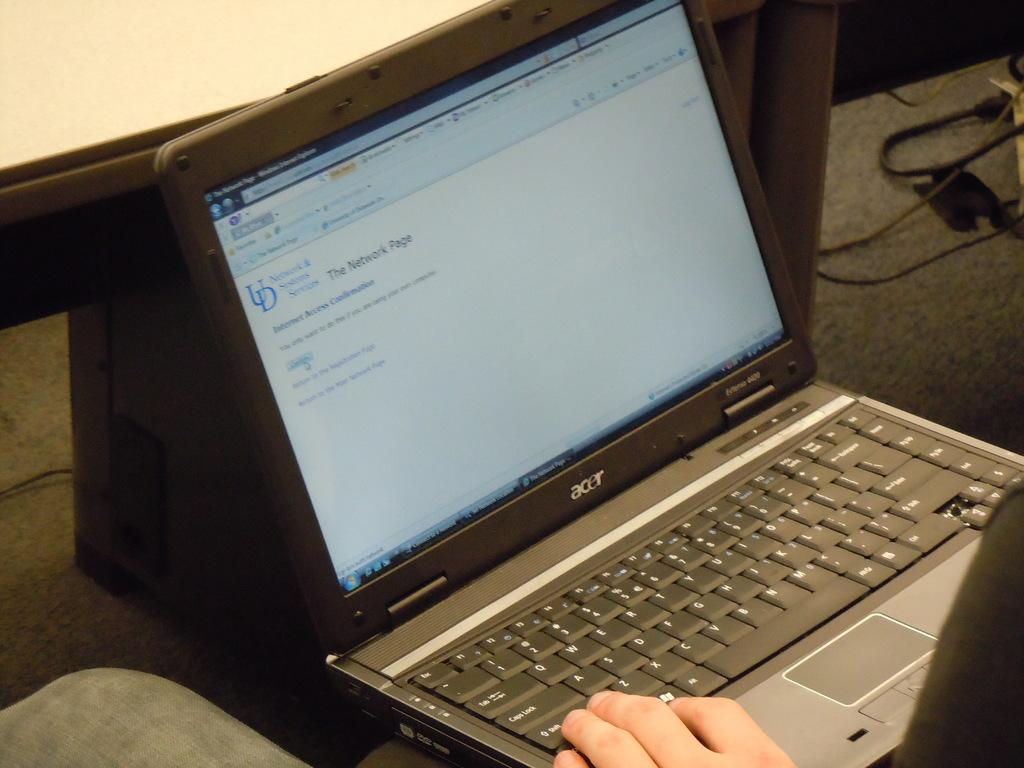<image>
Describe the image concisely. A man sits with his laptop in his lap looking at the network page on the screen. 